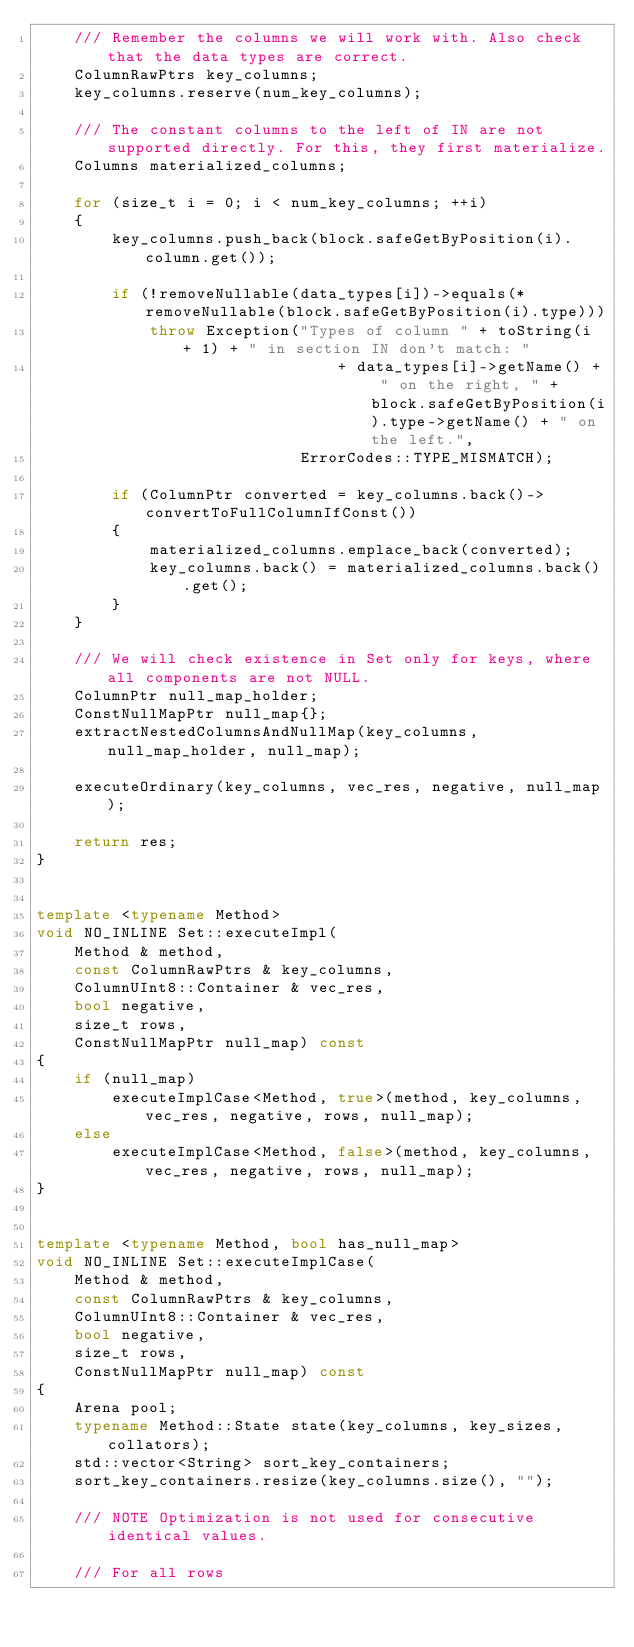Convert code to text. <code><loc_0><loc_0><loc_500><loc_500><_C++_>    /// Remember the columns we will work with. Also check that the data types are correct.
    ColumnRawPtrs key_columns;
    key_columns.reserve(num_key_columns);

    /// The constant columns to the left of IN are not supported directly. For this, they first materialize.
    Columns materialized_columns;

    for (size_t i = 0; i < num_key_columns; ++i)
    {
        key_columns.push_back(block.safeGetByPosition(i).column.get());

        if (!removeNullable(data_types[i])->equals(*removeNullable(block.safeGetByPosition(i).type)))
            throw Exception("Types of column " + toString(i + 1) + " in section IN don't match: "
                                + data_types[i]->getName() + " on the right, " + block.safeGetByPosition(i).type->getName() + " on the left.",
                            ErrorCodes::TYPE_MISMATCH);

        if (ColumnPtr converted = key_columns.back()->convertToFullColumnIfConst())
        {
            materialized_columns.emplace_back(converted);
            key_columns.back() = materialized_columns.back().get();
        }
    }

    /// We will check existence in Set only for keys, where all components are not NULL.
    ColumnPtr null_map_holder;
    ConstNullMapPtr null_map{};
    extractNestedColumnsAndNullMap(key_columns, null_map_holder, null_map);

    executeOrdinary(key_columns, vec_res, negative, null_map);

    return res;
}


template <typename Method>
void NO_INLINE Set::executeImpl(
    Method & method,
    const ColumnRawPtrs & key_columns,
    ColumnUInt8::Container & vec_res,
    bool negative,
    size_t rows,
    ConstNullMapPtr null_map) const
{
    if (null_map)
        executeImplCase<Method, true>(method, key_columns, vec_res, negative, rows, null_map);
    else
        executeImplCase<Method, false>(method, key_columns, vec_res, negative, rows, null_map);
}


template <typename Method, bool has_null_map>
void NO_INLINE Set::executeImplCase(
    Method & method,
    const ColumnRawPtrs & key_columns,
    ColumnUInt8::Container & vec_res,
    bool negative,
    size_t rows,
    ConstNullMapPtr null_map) const
{
    Arena pool;
    typename Method::State state(key_columns, key_sizes, collators);
    std::vector<String> sort_key_containers;
    sort_key_containers.resize(key_columns.size(), "");

    /// NOTE Optimization is not used for consecutive identical values.

    /// For all rows</code> 